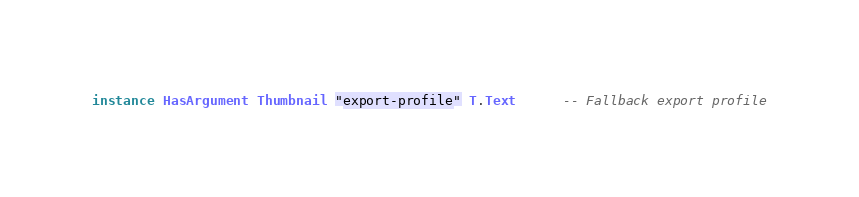<code> <loc_0><loc_0><loc_500><loc_500><_Haskell_>instance HasArgument Thumbnail "export-profile" T.Text      -- Fallback export profile</code> 